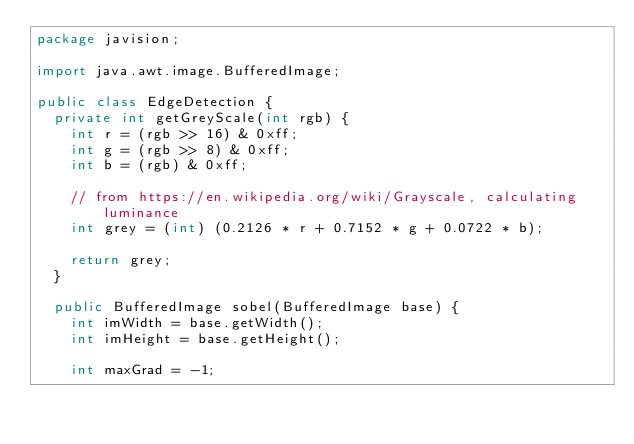<code> <loc_0><loc_0><loc_500><loc_500><_Java_>package javision;

import java.awt.image.BufferedImage;

public class EdgeDetection {
  private int getGreyScale(int rgb) {
    int r = (rgb >> 16) & 0xff;
    int g = (rgb >> 8) & 0xff;
    int b = (rgb) & 0xff;

    // from https://en.wikipedia.org/wiki/Grayscale, calculating luminance
    int grey = (int) (0.2126 * r + 0.7152 * g + 0.0722 * b);

    return grey;
  }

  public BufferedImage sobel(BufferedImage base) {
    int imWidth = base.getWidth();
    int imHeight = base.getHeight();

    int maxGrad = -1;</code> 